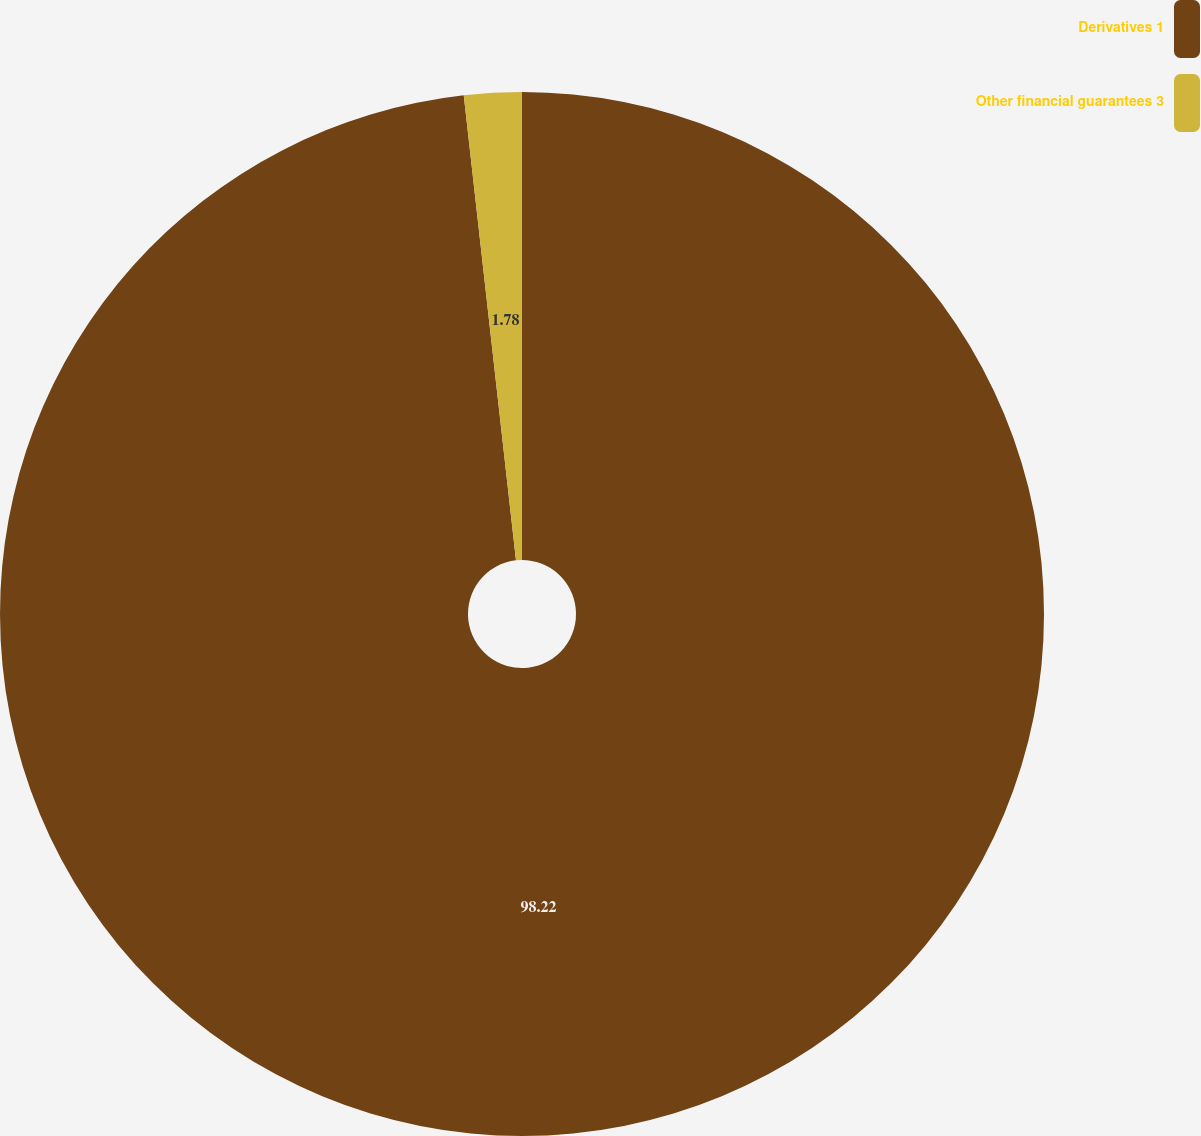Convert chart. <chart><loc_0><loc_0><loc_500><loc_500><pie_chart><fcel>Derivatives 1<fcel>Other financial guarantees 3<nl><fcel>98.22%<fcel>1.78%<nl></chart> 